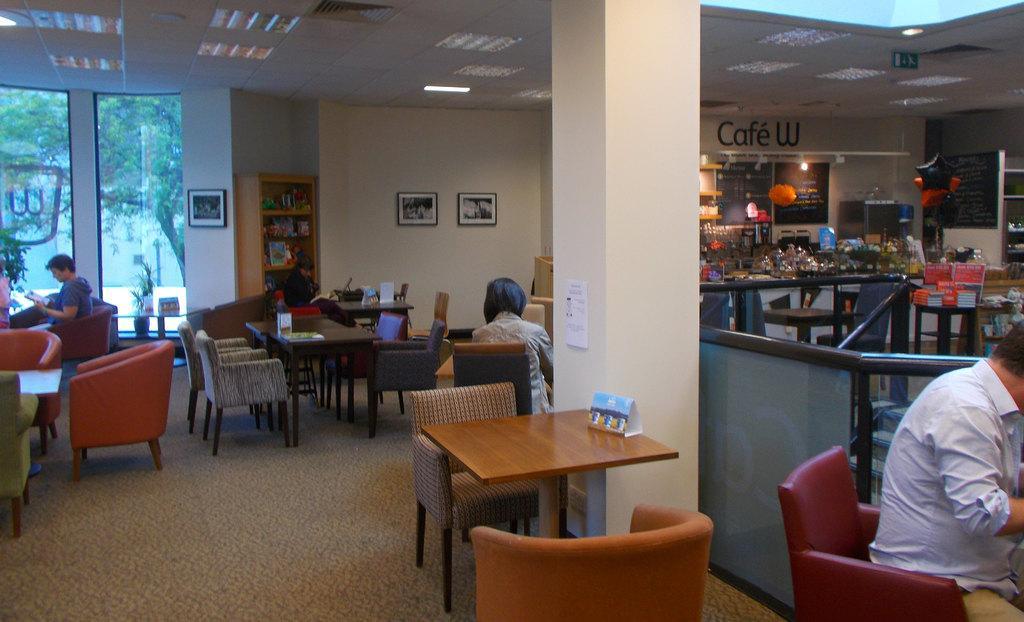Please provide a concise description of this image. In this picture there is a woman sitting on the chair and holding a book. There is also another woman who is wearing an off white jacket is sitting on the chair. There ia a man wearing purple shirt is also sitting on the chair. There is a shelf. There are three frames on the wall. There is a light. There are many objects on the table. 